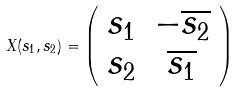<formula> <loc_0><loc_0><loc_500><loc_500>X ( s _ { 1 } , s _ { 2 } ) = \left ( \begin{array} { c c } s _ { 1 } & - \overline { s _ { 2 } } \\ s _ { 2 } & \overline { s _ { 1 } } \\ \end{array} \right )</formula> 